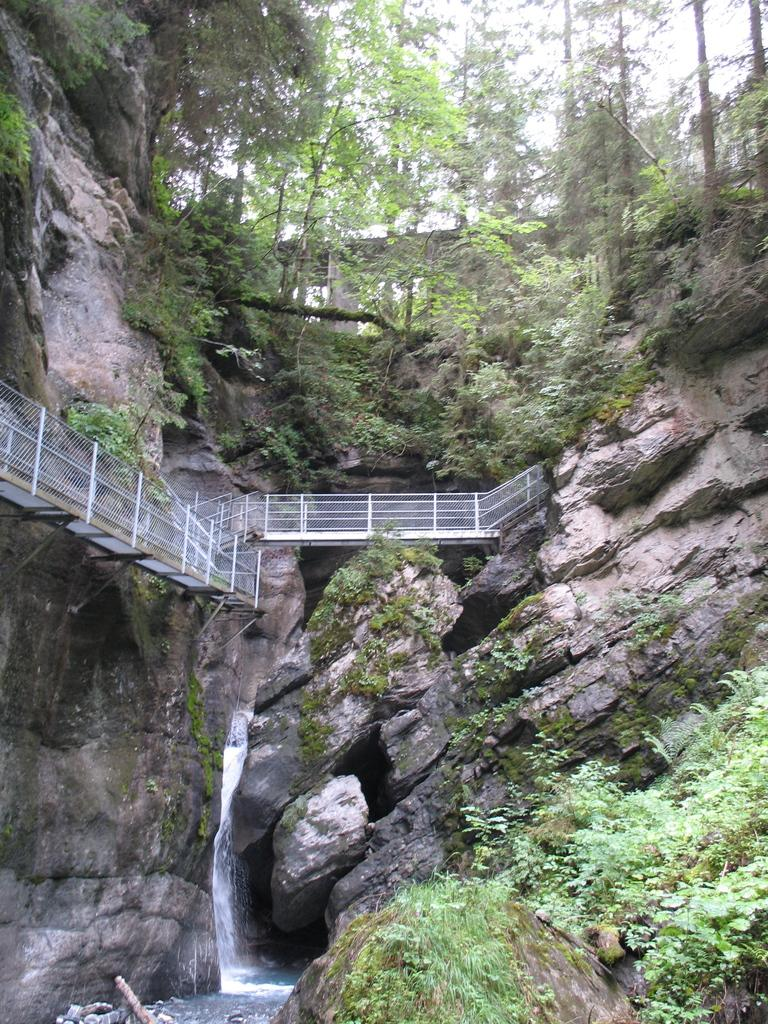What type of natural formation can be seen in the image? There are mountains in the image. What man-made structure is present in the image? There is a bridge in the image. What type of water feature can be seen in the image? There is a waterfall in the image. What type of vegetation is present in the image? There are plants and trees in the image. What type of board is being used for the journey in the image? There is no board or journey present in the image; it features mountains, a bridge, a waterfall, plants, and trees. 